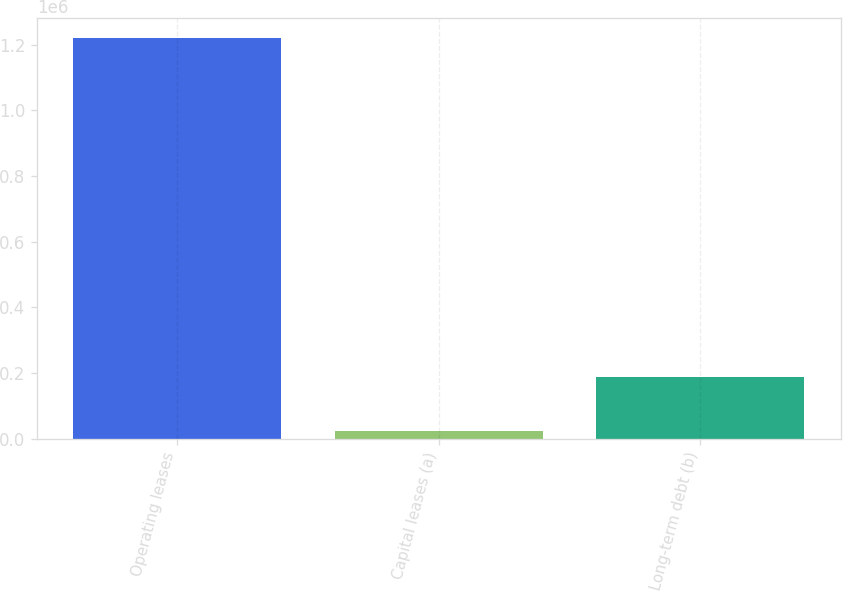Convert chart. <chart><loc_0><loc_0><loc_500><loc_500><bar_chart><fcel>Operating leases<fcel>Capital leases (a)<fcel>Long-term debt (b)<nl><fcel>1.21905e+06<fcel>23149<fcel>186784<nl></chart> 